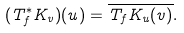<formula> <loc_0><loc_0><loc_500><loc_500>( T _ { f } ^ { * } K _ { v } ) ( u ) = { \overline { T _ { f } K _ { u } ( v ) } } .</formula> 